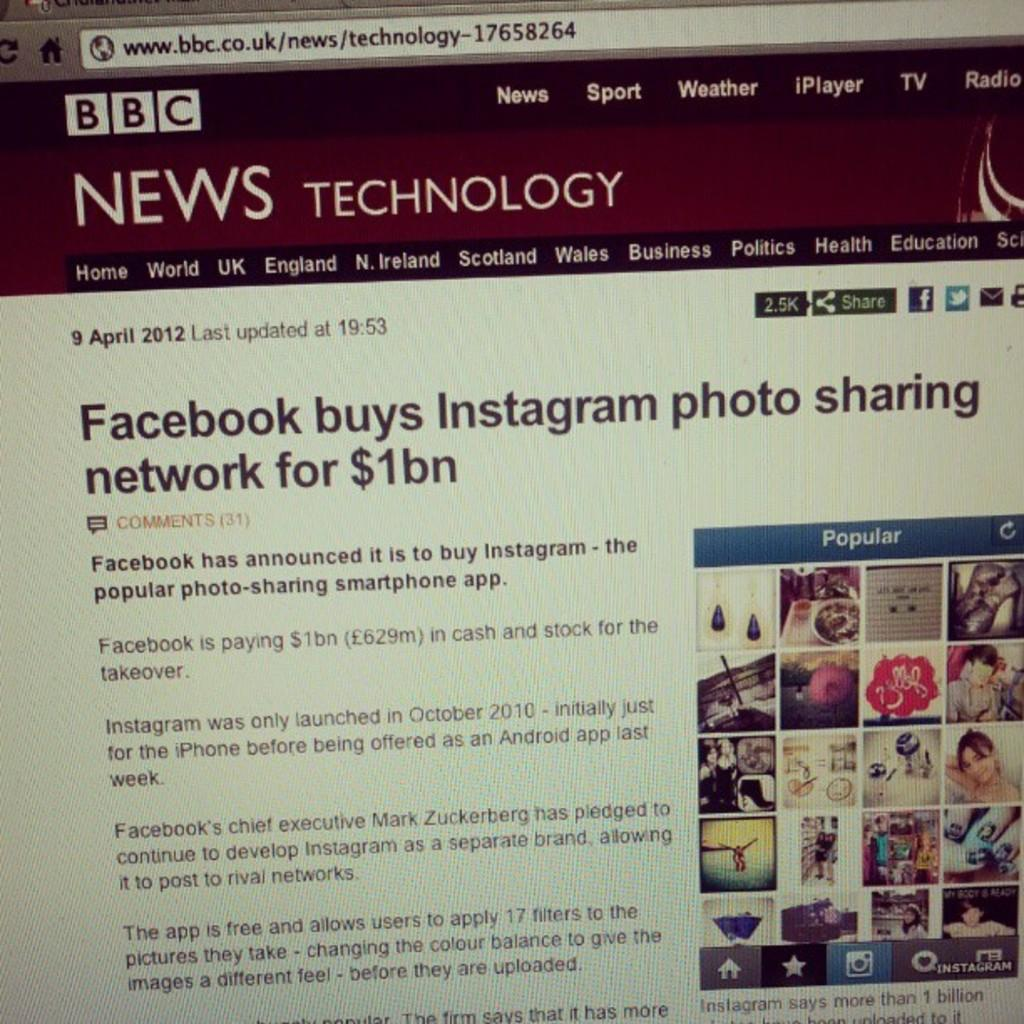What is the main subject of the image? The main subject of the image is a monitor screen. What is being displayed on the monitor screen? There is a website displayed on the screen. What types of content can be found on the website? The website contains text and images. How far away is the value of the item being displayed on the monitor screen? There is no value of an item being displayed on the monitor screen in the image, so it is not possible to determine the distance. 